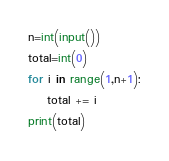<code> <loc_0><loc_0><loc_500><loc_500><_Python_>n=int(input())
total=int(0)
for i in range(1,n+1):
    total += i
print(total)
</code> 